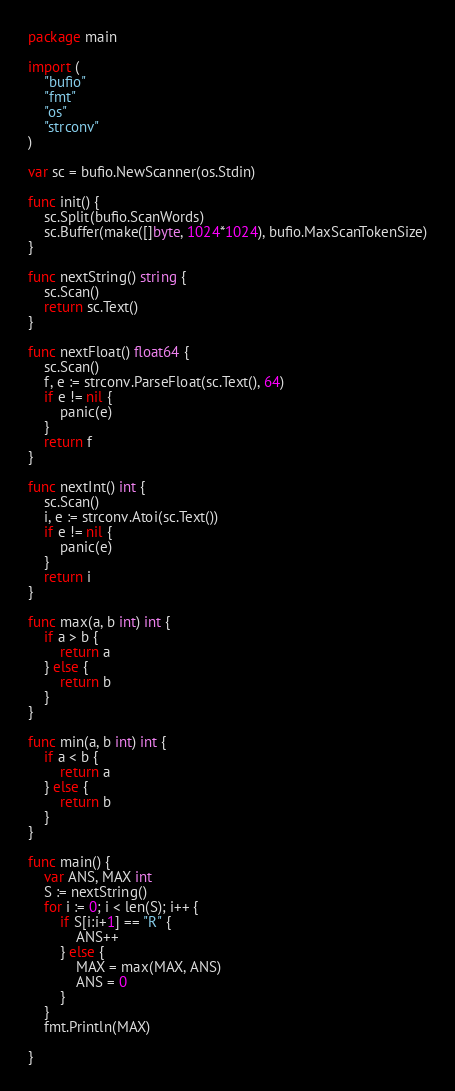<code> <loc_0><loc_0><loc_500><loc_500><_Go_>package main

import (
	"bufio"
	"fmt"
	"os"
	"strconv"
)

var sc = bufio.NewScanner(os.Stdin)

func init() {
	sc.Split(bufio.ScanWords)
	sc.Buffer(make([]byte, 1024*1024), bufio.MaxScanTokenSize)
}

func nextString() string {
	sc.Scan()
	return sc.Text()
}

func nextFloat() float64 {
	sc.Scan()
	f, e := strconv.ParseFloat(sc.Text(), 64)
	if e != nil {
		panic(e)
	}
	return f
}

func nextInt() int {
	sc.Scan()
	i, e := strconv.Atoi(sc.Text())
	if e != nil {
		panic(e)
	}
	return i
}

func max(a, b int) int {
	if a > b {
		return a
	} else {
		return b
	}
}

func min(a, b int) int {
	if a < b {
		return a
	} else {
		return b
	}
}

func main() {
	var ANS, MAX int
	S := nextString()
	for i := 0; i < len(S); i++ {
		if S[i:i+1] == "R" {
			ANS++
		} else {
			MAX = max(MAX, ANS)
			ANS = 0
		}
	}
	fmt.Println(MAX)

}
</code> 